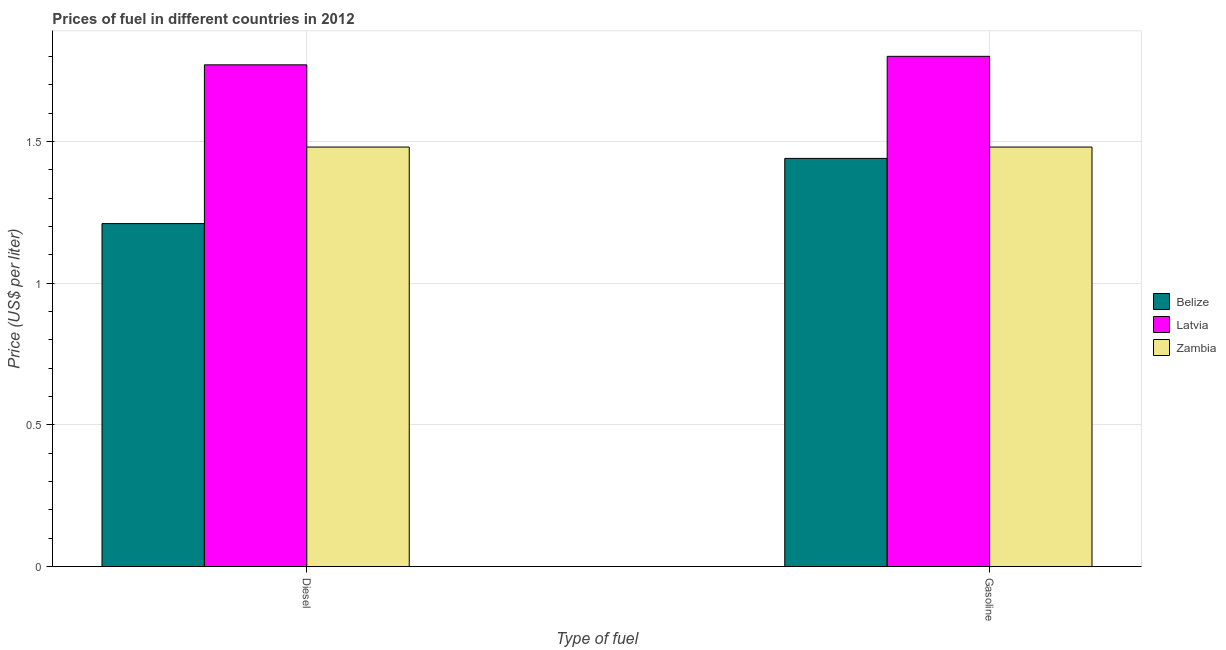How many groups of bars are there?
Your response must be concise. 2. Are the number of bars per tick equal to the number of legend labels?
Your answer should be compact. Yes. Are the number of bars on each tick of the X-axis equal?
Your response must be concise. Yes. How many bars are there on the 1st tick from the left?
Your answer should be compact. 3. What is the label of the 1st group of bars from the left?
Your answer should be very brief. Diesel. What is the diesel price in Zambia?
Your response must be concise. 1.48. Across all countries, what is the minimum gasoline price?
Provide a succinct answer. 1.44. In which country was the gasoline price maximum?
Your answer should be compact. Latvia. In which country was the gasoline price minimum?
Give a very brief answer. Belize. What is the total diesel price in the graph?
Provide a short and direct response. 4.46. What is the difference between the diesel price in Latvia and that in Belize?
Your answer should be compact. 0.56. What is the difference between the gasoline price in Latvia and the diesel price in Belize?
Your response must be concise. 0.59. What is the average diesel price per country?
Ensure brevity in your answer.  1.49. What is the difference between the gasoline price and diesel price in Latvia?
Make the answer very short. 0.03. What is the ratio of the gasoline price in Belize to that in Zambia?
Make the answer very short. 0.97. What does the 1st bar from the left in Diesel represents?
Your answer should be compact. Belize. What does the 1st bar from the right in Diesel represents?
Keep it short and to the point. Zambia. What is the difference between two consecutive major ticks on the Y-axis?
Provide a short and direct response. 0.5. Does the graph contain any zero values?
Offer a terse response. No. Does the graph contain grids?
Keep it short and to the point. Yes. How many legend labels are there?
Make the answer very short. 3. How are the legend labels stacked?
Make the answer very short. Vertical. What is the title of the graph?
Offer a very short reply. Prices of fuel in different countries in 2012. Does "Burkina Faso" appear as one of the legend labels in the graph?
Give a very brief answer. No. What is the label or title of the X-axis?
Offer a very short reply. Type of fuel. What is the label or title of the Y-axis?
Offer a terse response. Price (US$ per liter). What is the Price (US$ per liter) of Belize in Diesel?
Provide a succinct answer. 1.21. What is the Price (US$ per liter) in Latvia in Diesel?
Your answer should be very brief. 1.77. What is the Price (US$ per liter) in Zambia in Diesel?
Keep it short and to the point. 1.48. What is the Price (US$ per liter) of Belize in Gasoline?
Your answer should be very brief. 1.44. What is the Price (US$ per liter) of Zambia in Gasoline?
Offer a terse response. 1.48. Across all Type of fuel, what is the maximum Price (US$ per liter) in Belize?
Keep it short and to the point. 1.44. Across all Type of fuel, what is the maximum Price (US$ per liter) of Latvia?
Provide a succinct answer. 1.8. Across all Type of fuel, what is the maximum Price (US$ per liter) of Zambia?
Ensure brevity in your answer.  1.48. Across all Type of fuel, what is the minimum Price (US$ per liter) of Belize?
Your answer should be very brief. 1.21. Across all Type of fuel, what is the minimum Price (US$ per liter) of Latvia?
Give a very brief answer. 1.77. Across all Type of fuel, what is the minimum Price (US$ per liter) of Zambia?
Your answer should be very brief. 1.48. What is the total Price (US$ per liter) of Belize in the graph?
Provide a succinct answer. 2.65. What is the total Price (US$ per liter) in Latvia in the graph?
Your response must be concise. 3.57. What is the total Price (US$ per liter) of Zambia in the graph?
Your response must be concise. 2.96. What is the difference between the Price (US$ per liter) of Belize in Diesel and that in Gasoline?
Give a very brief answer. -0.23. What is the difference between the Price (US$ per liter) in Latvia in Diesel and that in Gasoline?
Your answer should be very brief. -0.03. What is the difference between the Price (US$ per liter) in Zambia in Diesel and that in Gasoline?
Make the answer very short. 0. What is the difference between the Price (US$ per liter) of Belize in Diesel and the Price (US$ per liter) of Latvia in Gasoline?
Make the answer very short. -0.59. What is the difference between the Price (US$ per liter) in Belize in Diesel and the Price (US$ per liter) in Zambia in Gasoline?
Your answer should be compact. -0.27. What is the difference between the Price (US$ per liter) of Latvia in Diesel and the Price (US$ per liter) of Zambia in Gasoline?
Offer a terse response. 0.29. What is the average Price (US$ per liter) in Belize per Type of fuel?
Ensure brevity in your answer.  1.32. What is the average Price (US$ per liter) in Latvia per Type of fuel?
Your answer should be very brief. 1.78. What is the average Price (US$ per liter) in Zambia per Type of fuel?
Ensure brevity in your answer.  1.48. What is the difference between the Price (US$ per liter) of Belize and Price (US$ per liter) of Latvia in Diesel?
Make the answer very short. -0.56. What is the difference between the Price (US$ per liter) in Belize and Price (US$ per liter) in Zambia in Diesel?
Make the answer very short. -0.27. What is the difference between the Price (US$ per liter) of Latvia and Price (US$ per liter) of Zambia in Diesel?
Give a very brief answer. 0.29. What is the difference between the Price (US$ per liter) of Belize and Price (US$ per liter) of Latvia in Gasoline?
Provide a succinct answer. -0.36. What is the difference between the Price (US$ per liter) in Belize and Price (US$ per liter) in Zambia in Gasoline?
Your response must be concise. -0.04. What is the difference between the Price (US$ per liter) of Latvia and Price (US$ per liter) of Zambia in Gasoline?
Offer a terse response. 0.32. What is the ratio of the Price (US$ per liter) of Belize in Diesel to that in Gasoline?
Your answer should be compact. 0.84. What is the ratio of the Price (US$ per liter) of Latvia in Diesel to that in Gasoline?
Your response must be concise. 0.98. What is the difference between the highest and the second highest Price (US$ per liter) of Belize?
Offer a very short reply. 0.23. What is the difference between the highest and the second highest Price (US$ per liter) of Zambia?
Give a very brief answer. 0. What is the difference between the highest and the lowest Price (US$ per liter) of Belize?
Make the answer very short. 0.23. What is the difference between the highest and the lowest Price (US$ per liter) of Latvia?
Give a very brief answer. 0.03. 